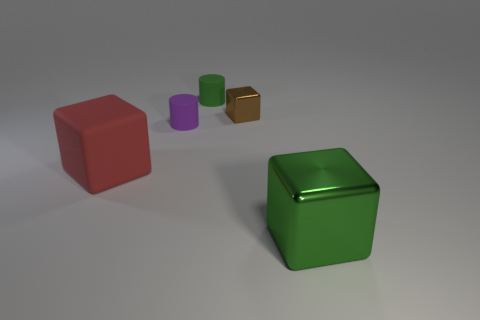Subtract all large cubes. How many cubes are left? 1 Add 4 purple shiny balls. How many objects exist? 9 Subtract all brown blocks. How many blocks are left? 2 Subtract 1 cubes. How many cubes are left? 2 Subtract all cylinders. How many objects are left? 3 Subtract all cyan cubes. Subtract all red balls. How many cubes are left? 3 Subtract all small blue matte things. Subtract all large red things. How many objects are left? 4 Add 3 tiny matte cylinders. How many tiny matte cylinders are left? 5 Add 3 purple matte cylinders. How many purple matte cylinders exist? 4 Subtract 0 gray cubes. How many objects are left? 5 